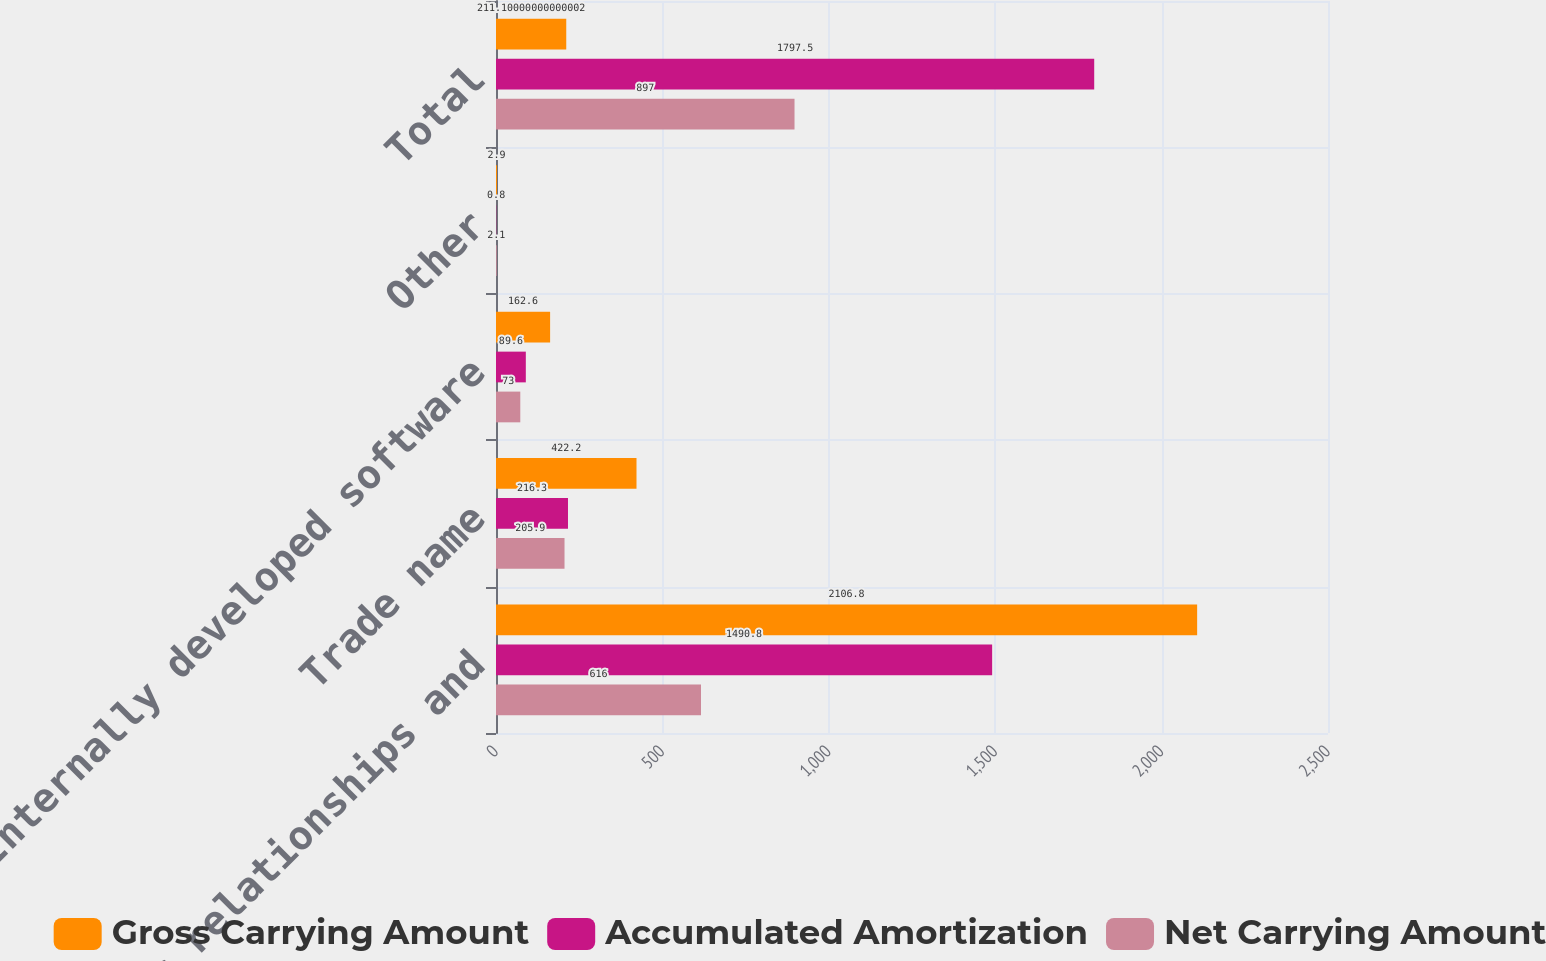<chart> <loc_0><loc_0><loc_500><loc_500><stacked_bar_chart><ecel><fcel>Customer relationships and<fcel>Trade name<fcel>Internally developed software<fcel>Other<fcel>Total<nl><fcel>Gross Carrying Amount<fcel>2106.8<fcel>422.2<fcel>162.6<fcel>2.9<fcel>211.1<nl><fcel>Accumulated Amortization<fcel>1490.8<fcel>216.3<fcel>89.6<fcel>0.8<fcel>1797.5<nl><fcel>Net Carrying Amount<fcel>616<fcel>205.9<fcel>73<fcel>2.1<fcel>897<nl></chart> 